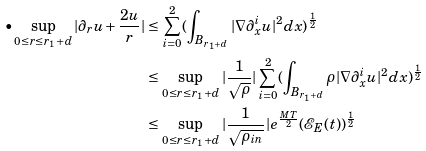Convert formula to latex. <formula><loc_0><loc_0><loc_500><loc_500>\bullet \sup _ { 0 \leq r \leq r _ { 1 } + d } | \partial _ { r } u + \frac { 2 u } { r } | & \leq \sum _ { i = 0 } ^ { 2 } ( \int _ { B _ { r _ { 1 } + d } } | \nabla \partial _ { x } ^ { i } u | ^ { 2 } d x ) ^ { \frac { 1 } { 2 } } \\ & \leq \sup _ { 0 \leq r \leq r _ { 1 } + d } | \frac { 1 } { \sqrt { \rho } } | \sum _ { i = 0 } ^ { 2 } ( \int _ { B _ { r _ { 1 } + d } } \rho | \nabla \partial _ { x } ^ { i } u | ^ { 2 } d x ) ^ { \frac { 1 } { 2 } } \\ & \leq \sup _ { 0 \leq r \leq r _ { 1 } + d } | \frac { 1 } { \sqrt { \rho _ { i n } } } | e ^ { \frac { M T } { 2 } } ( \mathcal { E } _ { E } ( t ) ) ^ { \frac { 1 } { 2 } }</formula> 